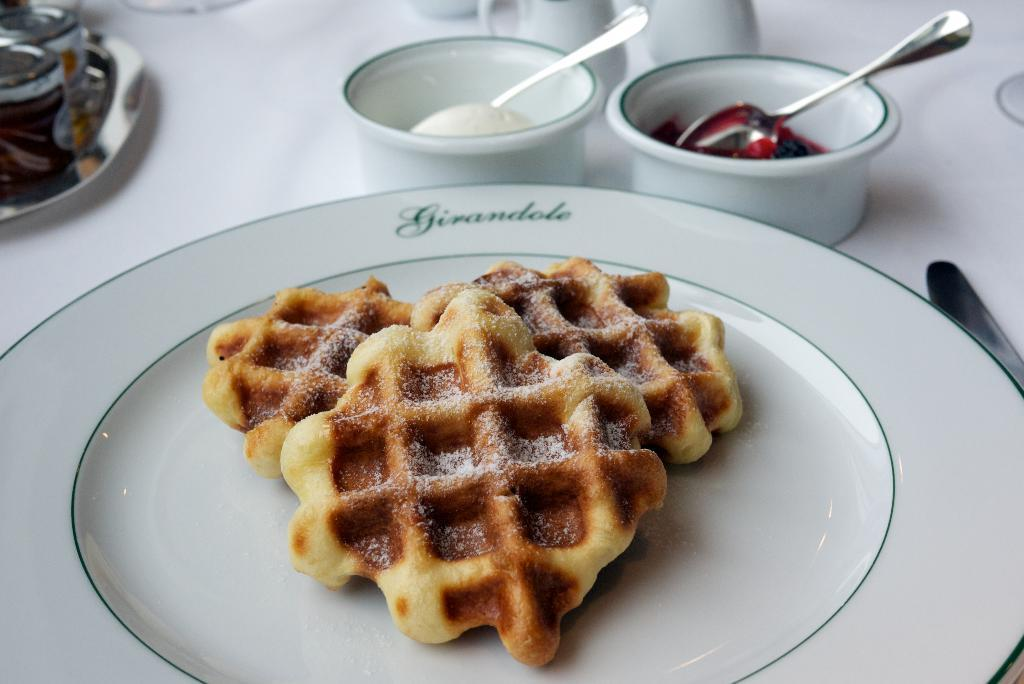What can be seen on the table in the image? A: There are different objects on the table in the image. What type of food is on the plate? There is food on a plate, but the specific type of food is not mentioned in the facts. What can be used for holding liquids in the image? There are cups present in the image. Are there any fairies flying around the table in the image? There is no mention of fairies in the facts, so we cannot say whether they are present or not. 